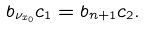Convert formula to latex. <formula><loc_0><loc_0><loc_500><loc_500>b _ { \nu _ { x _ { 0 } } } c _ { 1 } = b _ { n + 1 } c _ { 2 } .</formula> 